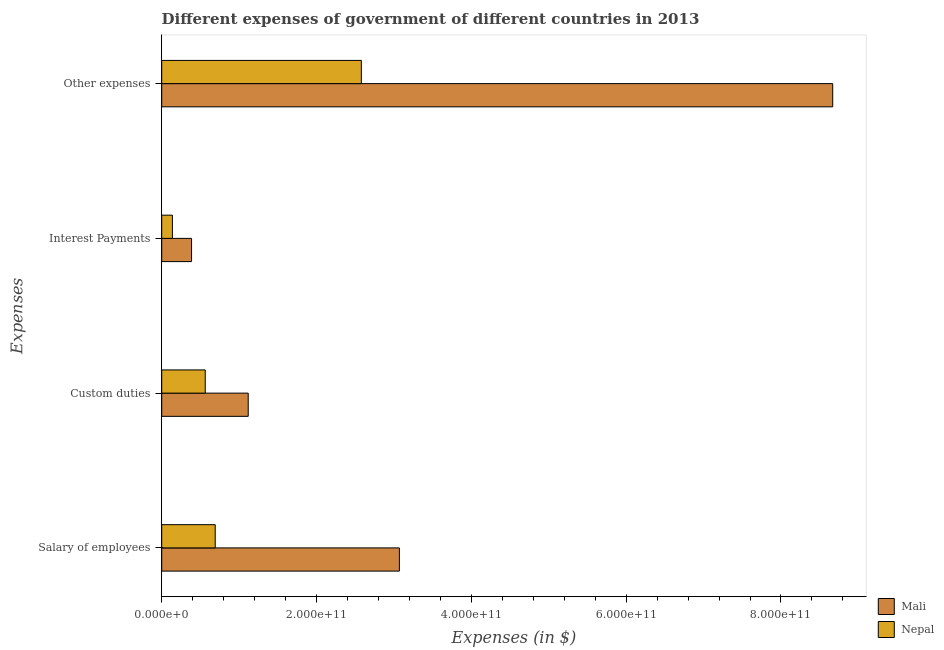Are the number of bars per tick equal to the number of legend labels?
Offer a very short reply. Yes. How many bars are there on the 2nd tick from the top?
Your response must be concise. 2. What is the label of the 3rd group of bars from the top?
Provide a succinct answer. Custom duties. What is the amount spent on salary of employees in Mali?
Ensure brevity in your answer.  3.07e+11. Across all countries, what is the maximum amount spent on interest payments?
Your answer should be compact. 3.86e+1. Across all countries, what is the minimum amount spent on other expenses?
Your answer should be compact. 2.58e+11. In which country was the amount spent on other expenses maximum?
Keep it short and to the point. Mali. In which country was the amount spent on other expenses minimum?
Make the answer very short. Nepal. What is the total amount spent on salary of employees in the graph?
Offer a very short reply. 3.76e+11. What is the difference between the amount spent on interest payments in Mali and that in Nepal?
Offer a very short reply. 2.47e+1. What is the difference between the amount spent on interest payments in Mali and the amount spent on other expenses in Nepal?
Provide a succinct answer. -2.19e+11. What is the average amount spent on salary of employees per country?
Offer a terse response. 1.88e+11. What is the difference between the amount spent on custom duties and amount spent on salary of employees in Mali?
Your answer should be very brief. -1.95e+11. What is the ratio of the amount spent on interest payments in Nepal to that in Mali?
Make the answer very short. 0.36. What is the difference between the highest and the second highest amount spent on salary of employees?
Your answer should be very brief. 2.38e+11. What is the difference between the highest and the lowest amount spent on other expenses?
Provide a short and direct response. 6.09e+11. What does the 1st bar from the top in Interest Payments represents?
Give a very brief answer. Nepal. What does the 1st bar from the bottom in Interest Payments represents?
Provide a short and direct response. Mali. Is it the case that in every country, the sum of the amount spent on salary of employees and amount spent on custom duties is greater than the amount spent on interest payments?
Make the answer very short. Yes. How many bars are there?
Provide a succinct answer. 8. How many countries are there in the graph?
Make the answer very short. 2. What is the difference between two consecutive major ticks on the X-axis?
Your answer should be compact. 2.00e+11. Does the graph contain any zero values?
Ensure brevity in your answer.  No. Does the graph contain grids?
Ensure brevity in your answer.  No. What is the title of the graph?
Your response must be concise. Different expenses of government of different countries in 2013. Does "Botswana" appear as one of the legend labels in the graph?
Your answer should be very brief. No. What is the label or title of the X-axis?
Your response must be concise. Expenses (in $). What is the label or title of the Y-axis?
Your answer should be very brief. Expenses. What is the Expenses (in $) of Mali in Salary of employees?
Give a very brief answer. 3.07e+11. What is the Expenses (in $) of Nepal in Salary of employees?
Make the answer very short. 6.91e+1. What is the Expenses (in $) of Mali in Custom duties?
Your response must be concise. 1.12e+11. What is the Expenses (in $) in Nepal in Custom duties?
Give a very brief answer. 5.62e+1. What is the Expenses (in $) in Mali in Interest Payments?
Give a very brief answer. 3.86e+1. What is the Expenses (in $) of Nepal in Interest Payments?
Provide a succinct answer. 1.38e+1. What is the Expenses (in $) in Mali in Other expenses?
Offer a terse response. 8.67e+11. What is the Expenses (in $) of Nepal in Other expenses?
Ensure brevity in your answer.  2.58e+11. Across all Expenses, what is the maximum Expenses (in $) of Mali?
Keep it short and to the point. 8.67e+11. Across all Expenses, what is the maximum Expenses (in $) in Nepal?
Offer a very short reply. 2.58e+11. Across all Expenses, what is the minimum Expenses (in $) in Mali?
Give a very brief answer. 3.86e+1. Across all Expenses, what is the minimum Expenses (in $) of Nepal?
Offer a terse response. 1.38e+1. What is the total Expenses (in $) in Mali in the graph?
Offer a terse response. 1.32e+12. What is the total Expenses (in $) of Nepal in the graph?
Provide a succinct answer. 3.97e+11. What is the difference between the Expenses (in $) in Mali in Salary of employees and that in Custom duties?
Give a very brief answer. 1.95e+11. What is the difference between the Expenses (in $) in Nepal in Salary of employees and that in Custom duties?
Your answer should be compact. 1.29e+1. What is the difference between the Expenses (in $) of Mali in Salary of employees and that in Interest Payments?
Keep it short and to the point. 2.68e+11. What is the difference between the Expenses (in $) in Nepal in Salary of employees and that in Interest Payments?
Make the answer very short. 5.53e+1. What is the difference between the Expenses (in $) in Mali in Salary of employees and that in Other expenses?
Offer a terse response. -5.60e+11. What is the difference between the Expenses (in $) of Nepal in Salary of employees and that in Other expenses?
Give a very brief answer. -1.89e+11. What is the difference between the Expenses (in $) in Mali in Custom duties and that in Interest Payments?
Make the answer very short. 7.32e+1. What is the difference between the Expenses (in $) of Nepal in Custom duties and that in Interest Payments?
Provide a succinct answer. 4.24e+1. What is the difference between the Expenses (in $) in Mali in Custom duties and that in Other expenses?
Keep it short and to the point. -7.55e+11. What is the difference between the Expenses (in $) of Nepal in Custom duties and that in Other expenses?
Your answer should be compact. -2.02e+11. What is the difference between the Expenses (in $) in Mali in Interest Payments and that in Other expenses?
Your response must be concise. -8.28e+11. What is the difference between the Expenses (in $) of Nepal in Interest Payments and that in Other expenses?
Make the answer very short. -2.44e+11. What is the difference between the Expenses (in $) of Mali in Salary of employees and the Expenses (in $) of Nepal in Custom duties?
Provide a short and direct response. 2.51e+11. What is the difference between the Expenses (in $) of Mali in Salary of employees and the Expenses (in $) of Nepal in Interest Payments?
Your response must be concise. 2.93e+11. What is the difference between the Expenses (in $) of Mali in Salary of employees and the Expenses (in $) of Nepal in Other expenses?
Offer a terse response. 4.91e+1. What is the difference between the Expenses (in $) in Mali in Custom duties and the Expenses (in $) in Nepal in Interest Payments?
Give a very brief answer. 9.80e+1. What is the difference between the Expenses (in $) of Mali in Custom duties and the Expenses (in $) of Nepal in Other expenses?
Offer a terse response. -1.46e+11. What is the difference between the Expenses (in $) of Mali in Interest Payments and the Expenses (in $) of Nepal in Other expenses?
Ensure brevity in your answer.  -2.19e+11. What is the average Expenses (in $) of Mali per Expenses?
Provide a succinct answer. 3.31e+11. What is the average Expenses (in $) in Nepal per Expenses?
Ensure brevity in your answer.  9.93e+1. What is the difference between the Expenses (in $) in Mali and Expenses (in $) in Nepal in Salary of employees?
Provide a succinct answer. 2.38e+11. What is the difference between the Expenses (in $) of Mali and Expenses (in $) of Nepal in Custom duties?
Offer a terse response. 5.55e+1. What is the difference between the Expenses (in $) of Mali and Expenses (in $) of Nepal in Interest Payments?
Offer a very short reply. 2.47e+1. What is the difference between the Expenses (in $) of Mali and Expenses (in $) of Nepal in Other expenses?
Your answer should be very brief. 6.09e+11. What is the ratio of the Expenses (in $) of Mali in Salary of employees to that in Custom duties?
Your response must be concise. 2.75. What is the ratio of the Expenses (in $) in Nepal in Salary of employees to that in Custom duties?
Your answer should be very brief. 1.23. What is the ratio of the Expenses (in $) of Mali in Salary of employees to that in Interest Payments?
Keep it short and to the point. 7.96. What is the ratio of the Expenses (in $) in Nepal in Salary of employees to that in Interest Payments?
Provide a succinct answer. 5.01. What is the ratio of the Expenses (in $) in Mali in Salary of employees to that in Other expenses?
Offer a terse response. 0.35. What is the ratio of the Expenses (in $) of Nepal in Salary of employees to that in Other expenses?
Your response must be concise. 0.27. What is the ratio of the Expenses (in $) in Mali in Custom duties to that in Interest Payments?
Give a very brief answer. 2.9. What is the ratio of the Expenses (in $) in Nepal in Custom duties to that in Interest Payments?
Provide a short and direct response. 4.07. What is the ratio of the Expenses (in $) in Mali in Custom duties to that in Other expenses?
Make the answer very short. 0.13. What is the ratio of the Expenses (in $) of Nepal in Custom duties to that in Other expenses?
Make the answer very short. 0.22. What is the ratio of the Expenses (in $) in Mali in Interest Payments to that in Other expenses?
Your answer should be very brief. 0.04. What is the ratio of the Expenses (in $) in Nepal in Interest Payments to that in Other expenses?
Ensure brevity in your answer.  0.05. What is the difference between the highest and the second highest Expenses (in $) of Mali?
Your answer should be very brief. 5.60e+11. What is the difference between the highest and the second highest Expenses (in $) of Nepal?
Give a very brief answer. 1.89e+11. What is the difference between the highest and the lowest Expenses (in $) of Mali?
Give a very brief answer. 8.28e+11. What is the difference between the highest and the lowest Expenses (in $) of Nepal?
Your answer should be very brief. 2.44e+11. 